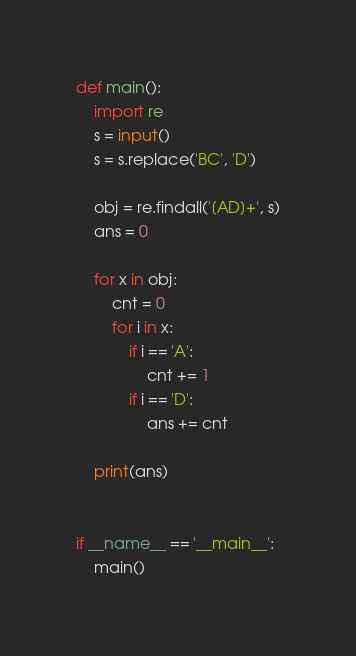<code> <loc_0><loc_0><loc_500><loc_500><_Python_>def main():
    import re
    s = input()
    s = s.replace('BC', 'D')

    obj = re.findall('[AD]+', s)
    ans = 0

    for x in obj:
        cnt = 0
        for i in x:
            if i == 'A':
                cnt += 1
            if i == 'D':
                ans += cnt

    print(ans)


if __name__ == '__main__':
    main()
</code> 